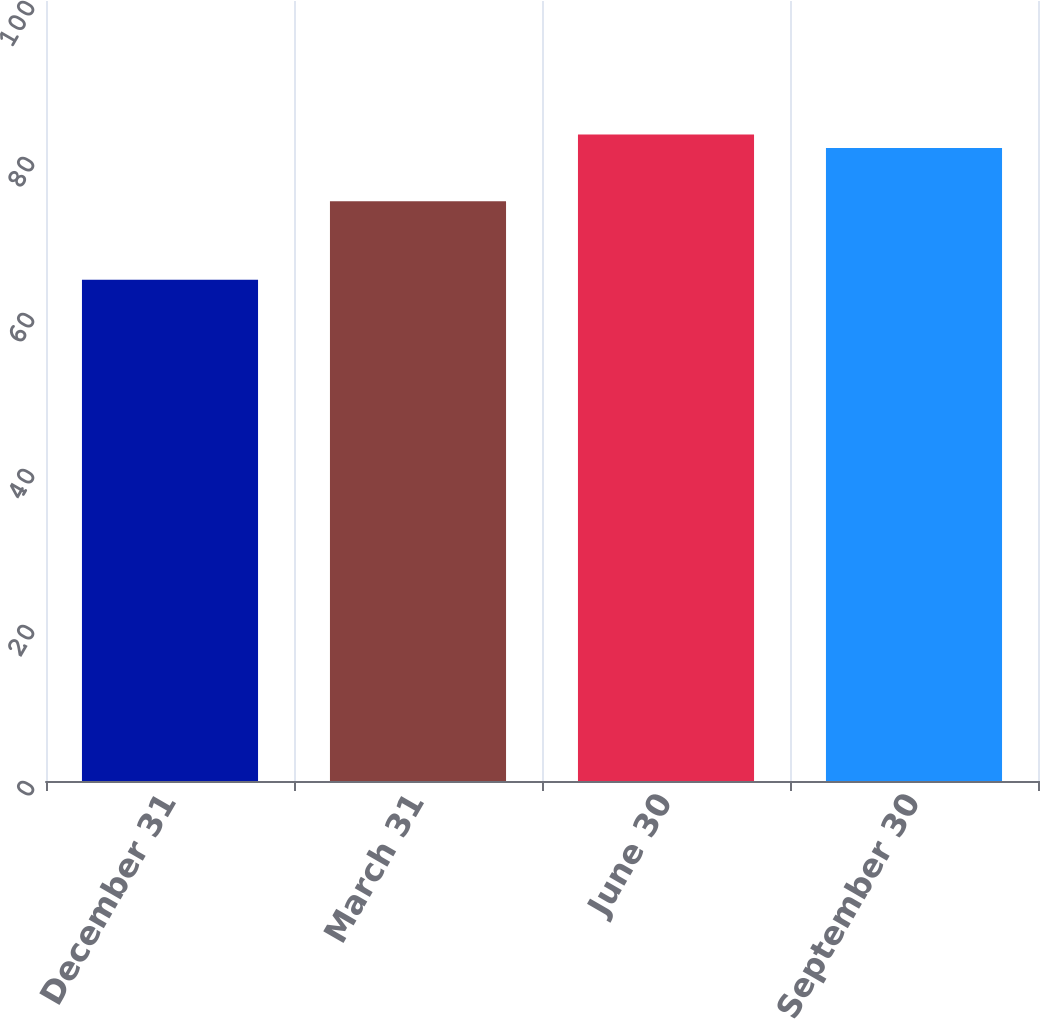Convert chart. <chart><loc_0><loc_0><loc_500><loc_500><bar_chart><fcel>December 31<fcel>March 31<fcel>June 30<fcel>September 30<nl><fcel>64.25<fcel>74.33<fcel>82.87<fcel>81.16<nl></chart> 